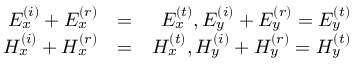<formula> <loc_0><loc_0><loc_500><loc_500>\begin{array} { r l r } { E _ { x } ^ { \left ( i \right ) } + E _ { x } ^ { \left ( r \right ) } } & { = } & { E _ { x } ^ { \left ( t \right ) } , E _ { y } ^ { \left ( i \right ) } + E _ { y } ^ { \left ( r \right ) } = E _ { y } ^ { \left ( t \right ) } } \\ { H _ { x } ^ { \left ( i \right ) } + H _ { x } ^ { \left ( r \right ) } } & { = } & { H _ { x } ^ { \left ( t \right ) } , H _ { y } ^ { \left ( i \right ) } + H _ { y } ^ { \left ( r \right ) } = H _ { y } ^ { \left ( t \right ) } } \end{array}</formula> 